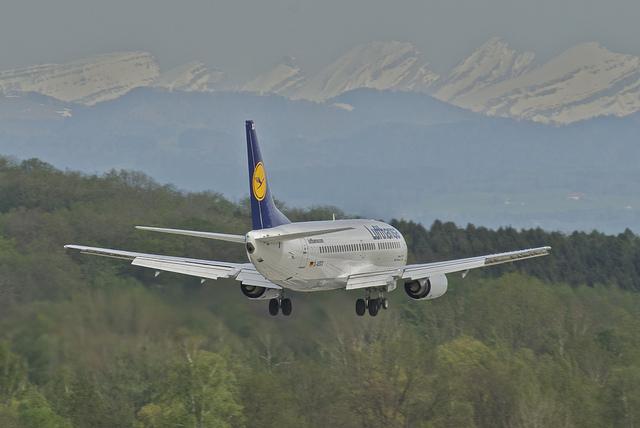Does this plane have 4 wheels?
Write a very short answer. Yes. Will this plane fly over the mountains?
Quick response, please. Yes. Was this mode of transportation available 200 years ago?
Write a very short answer. No. 